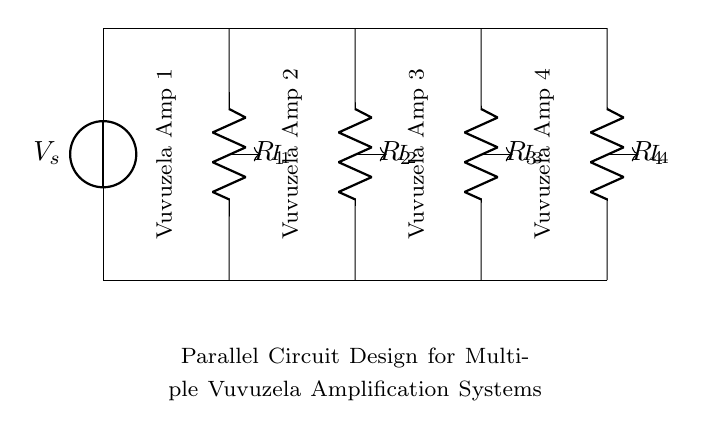What is the total number of resistors in this circuit? The circuit diagram shows a total of four resistors labeled R1, R2, R3, and R4. These are used in parallel, making it a parallel circuit configuration.
Answer: 4 What is the current flowing through the first amplifier? The current flowing through the first amplifier is denoted as I1, which is represented on the diagram as a current arrow pointing away from the resistor R1.
Answer: I1 What is the role of the voltage source in this circuit? The voltage source, labeled as Vs, provides the necessary electrical potential to the entire circuit. This potential is what enables current to flow through the resistors and, consequently, the vuvuzela amplifiers.
Answer: Power supply Which resistor has the highest resistance in this design? The circuit does not provide specific values for the resistors R1, R2, R3, and R4. Therefore, without numerical values, we cannot determine which resistor has the highest resistance. However, one could compare application or specifications to deduce this in practice.
Answer: Cannot determine How does current distribute among the amplifiers? The current divides among the parallel branches according to the resistance values of each resistor. The lower the resistance, the higher the current flowing through that branch, given the same voltage is applied to all branches. This division is characteristic of a current divider circuit.
Answer: According to resistance values What is the equivalent resistance of this circuit? To find the equivalent resistance of a parallel circuit, you can use the formula: 1/Req = 1/R1 + 1/R2 + 1/R3 + 1/R4. However, this cannot be calculated without knowing the individual values of R1, R2, R3, and R4. This formula shows how parallel resistances affect the overall resistance decrease in the circuit.
Answer: Cannot calculate without values What is the purpose of using multiple amplifiers in this circuit? Using multiple amplifiers allows for enhanced sound amplification capabilities. Each amplifier receives a portion of the total current, ensuring that the sound is evenly distributed and more powerful at the cheering event. This design is particularly effective for creating a strong and clear sound from multiple vuvuzelas.
Answer: Enhanced sound amplification 